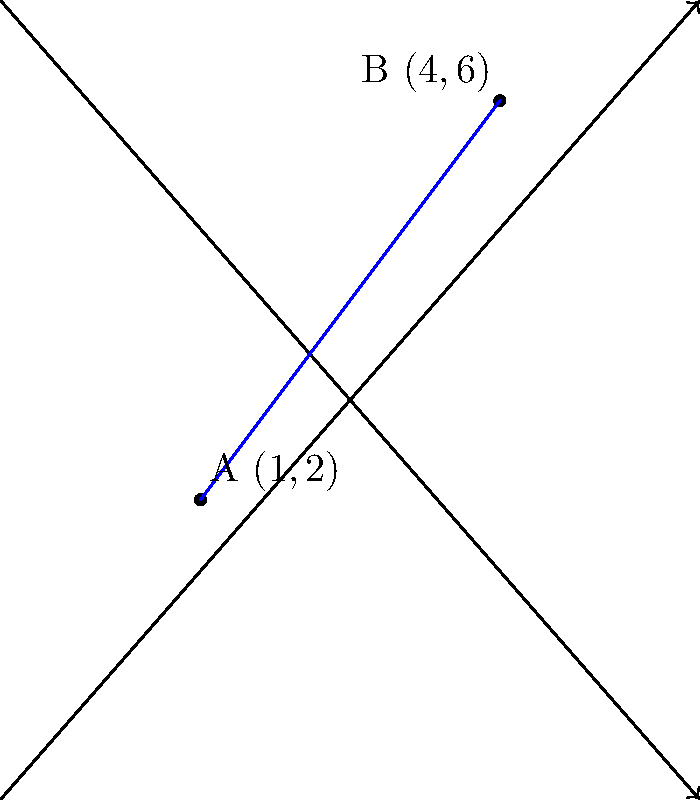Two spiritual centers are located on a coordinate plane. Spiritual Center 1 is at point A(1,2) and Spiritual Center 2 is at point B(4,6). Calculate the distance between these two spiritual centers, representing the metaphysical connection between them. How might this distance relate to the spiritual bond between different forms of life? To find the distance between two points on a coordinate plane, we use the distance formula, which is derived from the Pythagorean theorem:

$$d = \sqrt{(x_2 - x_1)^2 + (y_2 - y_1)^2}$$

Where $(x_1, y_1)$ are the coordinates of the first point and $(x_2, y_2)$ are the coordinates of the second point.

Let's apply this formula to our spiritual centers:

1) Identify the coordinates:
   Point A (Spiritual Center 1): $(x_1, y_1) = (1, 2)$
   Point B (Spiritual Center 2): $(x_2, y_2) = (4, 6)$

2) Plug these values into the distance formula:
   $$d = \sqrt{(4 - 1)^2 + (6 - 2)^2}$$

3) Simplify the expressions inside the parentheses:
   $$d = \sqrt{3^2 + 4^2}$$

4) Calculate the squares:
   $$d = \sqrt{9 + 16}$$

5) Add under the square root:
   $$d = \sqrt{25}$$

6) Simplify the square root:
   $$d = 5$$

Therefore, the distance between the two spiritual centers is 5 units.

Reflecting on this result, we can consider how this measurable distance might represent the interconnectedness of all living beings. Just as these two points are connected by a definite distance on the coordinate plane, all forms of life are connected in the grand tapestry of creation. The distance of 5 units could symbolize the five elements in many spiritual traditions (earth, water, fire, air, and ether) that connect all life forms.
Answer: 5 units 